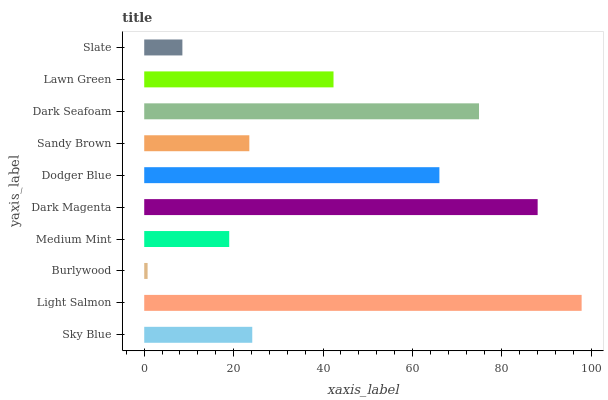Is Burlywood the minimum?
Answer yes or no. Yes. Is Light Salmon the maximum?
Answer yes or no. Yes. Is Light Salmon the minimum?
Answer yes or no. No. Is Burlywood the maximum?
Answer yes or no. No. Is Light Salmon greater than Burlywood?
Answer yes or no. Yes. Is Burlywood less than Light Salmon?
Answer yes or no. Yes. Is Burlywood greater than Light Salmon?
Answer yes or no. No. Is Light Salmon less than Burlywood?
Answer yes or no. No. Is Lawn Green the high median?
Answer yes or no. Yes. Is Sky Blue the low median?
Answer yes or no. Yes. Is Burlywood the high median?
Answer yes or no. No. Is Light Salmon the low median?
Answer yes or no. No. 